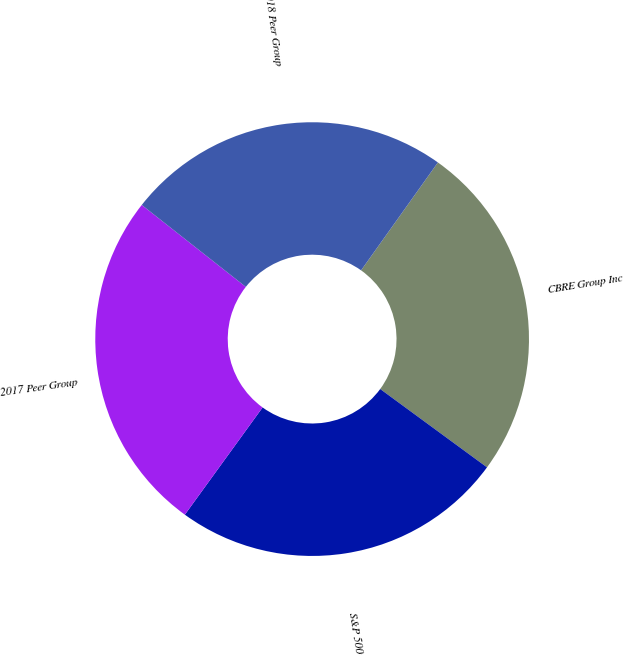Convert chart to OTSL. <chart><loc_0><loc_0><loc_500><loc_500><pie_chart><fcel>CBRE Group Inc<fcel>S&P 500<fcel>2017 Peer Group<fcel>2018 Peer Group<nl><fcel>25.22%<fcel>24.91%<fcel>25.63%<fcel>24.23%<nl></chart> 